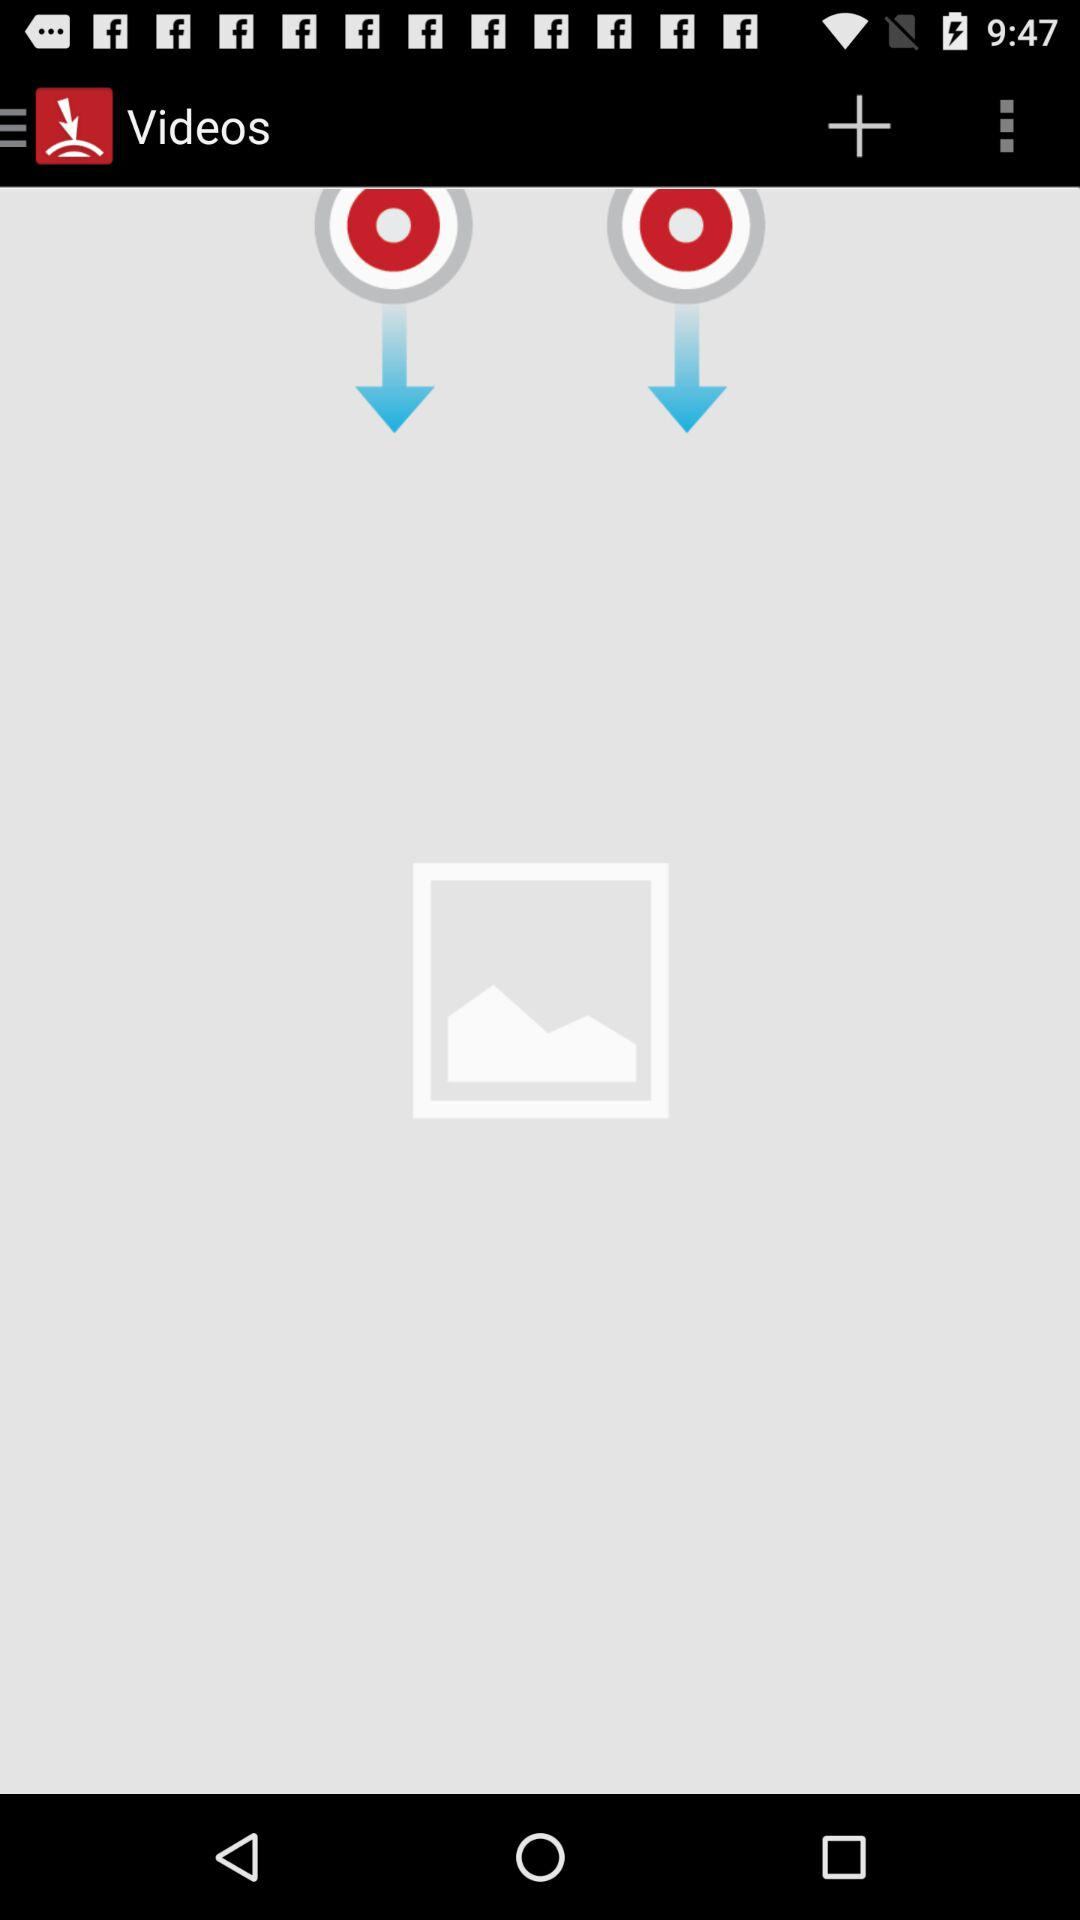What is the application name?
When the provided information is insufficient, respond with <no answer>. <no answer> 